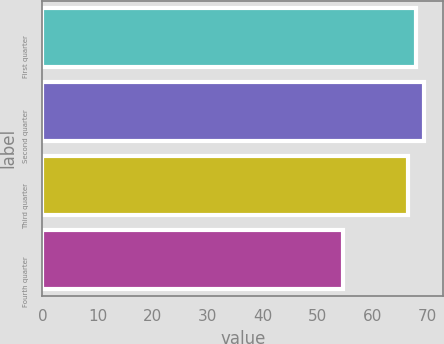Convert chart to OTSL. <chart><loc_0><loc_0><loc_500><loc_500><bar_chart><fcel>First quarter<fcel>Second quarter<fcel>Third quarter<fcel>Fourth quarter<nl><fcel>67.95<fcel>69.42<fcel>66.48<fcel>54.7<nl></chart> 